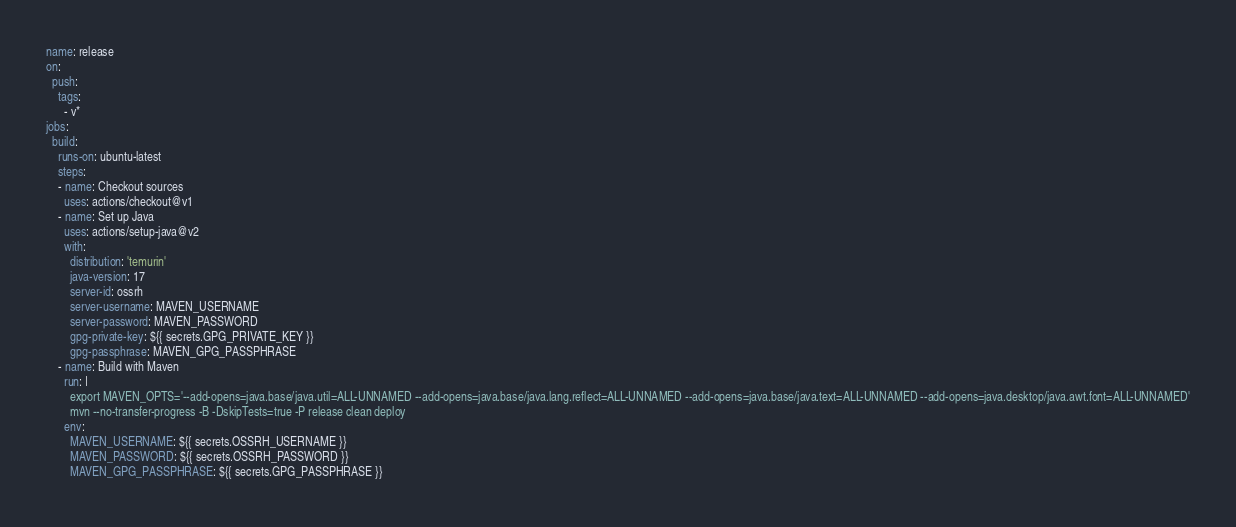<code> <loc_0><loc_0><loc_500><loc_500><_YAML_>name: release
on:
  push:
    tags:        
      - v*
jobs:
  build:
    runs-on: ubuntu-latest
    steps:
    - name: Checkout sources
      uses: actions/checkout@v1
    - name: Set up Java
      uses: actions/setup-java@v2
      with:
        distribution: 'temurin'
        java-version: 17
        server-id: ossrh
        server-username: MAVEN_USERNAME
        server-password: MAVEN_PASSWORD
        gpg-private-key: ${{ secrets.GPG_PRIVATE_KEY }}
        gpg-passphrase: MAVEN_GPG_PASSPHRASE
    - name: Build with Maven
      run: |
        export MAVEN_OPTS='--add-opens=java.base/java.util=ALL-UNNAMED --add-opens=java.base/java.lang.reflect=ALL-UNNAMED --add-opens=java.base/java.text=ALL-UNNAMED --add-opens=java.desktop/java.awt.font=ALL-UNNAMED'
        mvn --no-transfer-progress -B -DskipTests=true -P release clean deploy
      env:
        MAVEN_USERNAME: ${{ secrets.OSSRH_USERNAME }}
        MAVEN_PASSWORD: ${{ secrets.OSSRH_PASSWORD }}
        MAVEN_GPG_PASSPHRASE: ${{ secrets.GPG_PASSPHRASE }}
</code> 